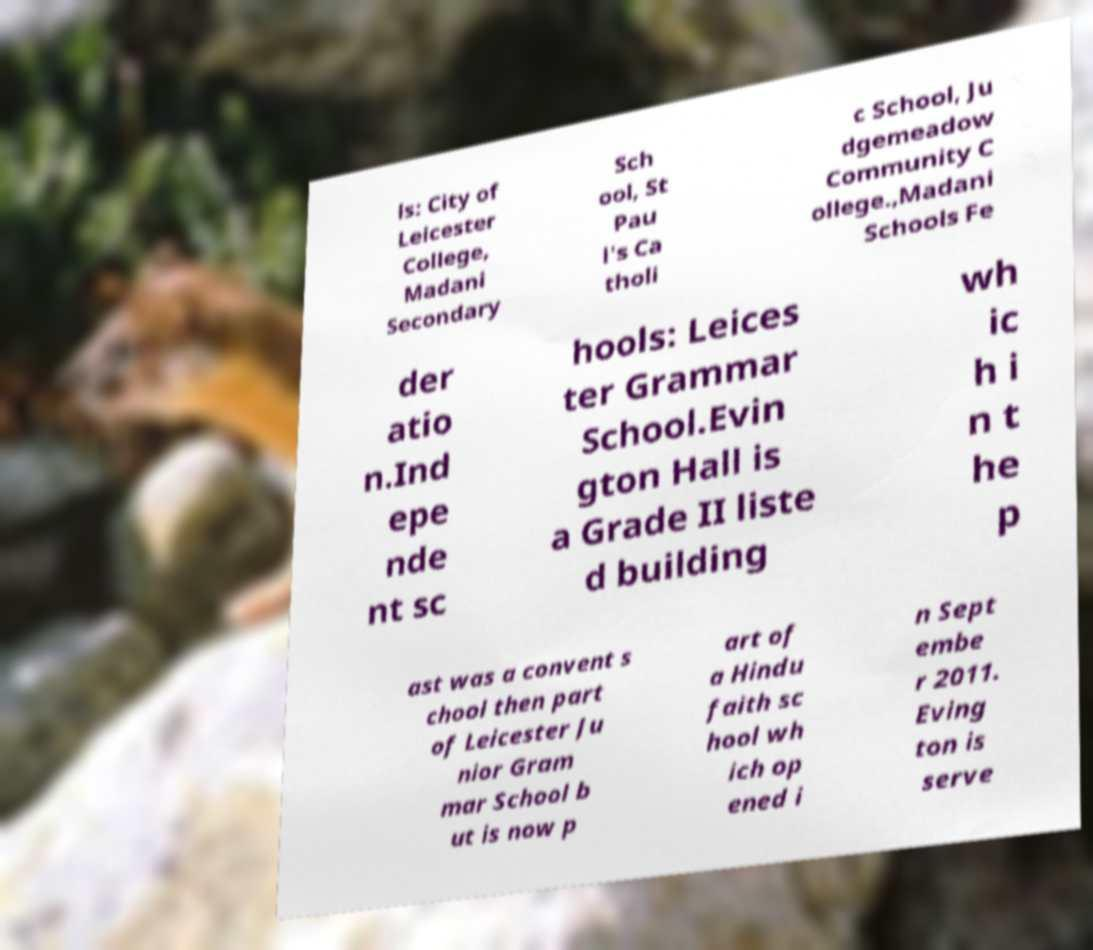What messages or text are displayed in this image? I need them in a readable, typed format. ls: City of Leicester College, Madani Secondary Sch ool, St Pau l's Ca tholi c School, Ju dgemeadow Community C ollege.,Madani Schools Fe der atio n.Ind epe nde nt sc hools: Leices ter Grammar School.Evin gton Hall is a Grade II liste d building wh ic h i n t he p ast was a convent s chool then part of Leicester Ju nior Gram mar School b ut is now p art of a Hindu faith sc hool wh ich op ened i n Sept embe r 2011. Eving ton is serve 